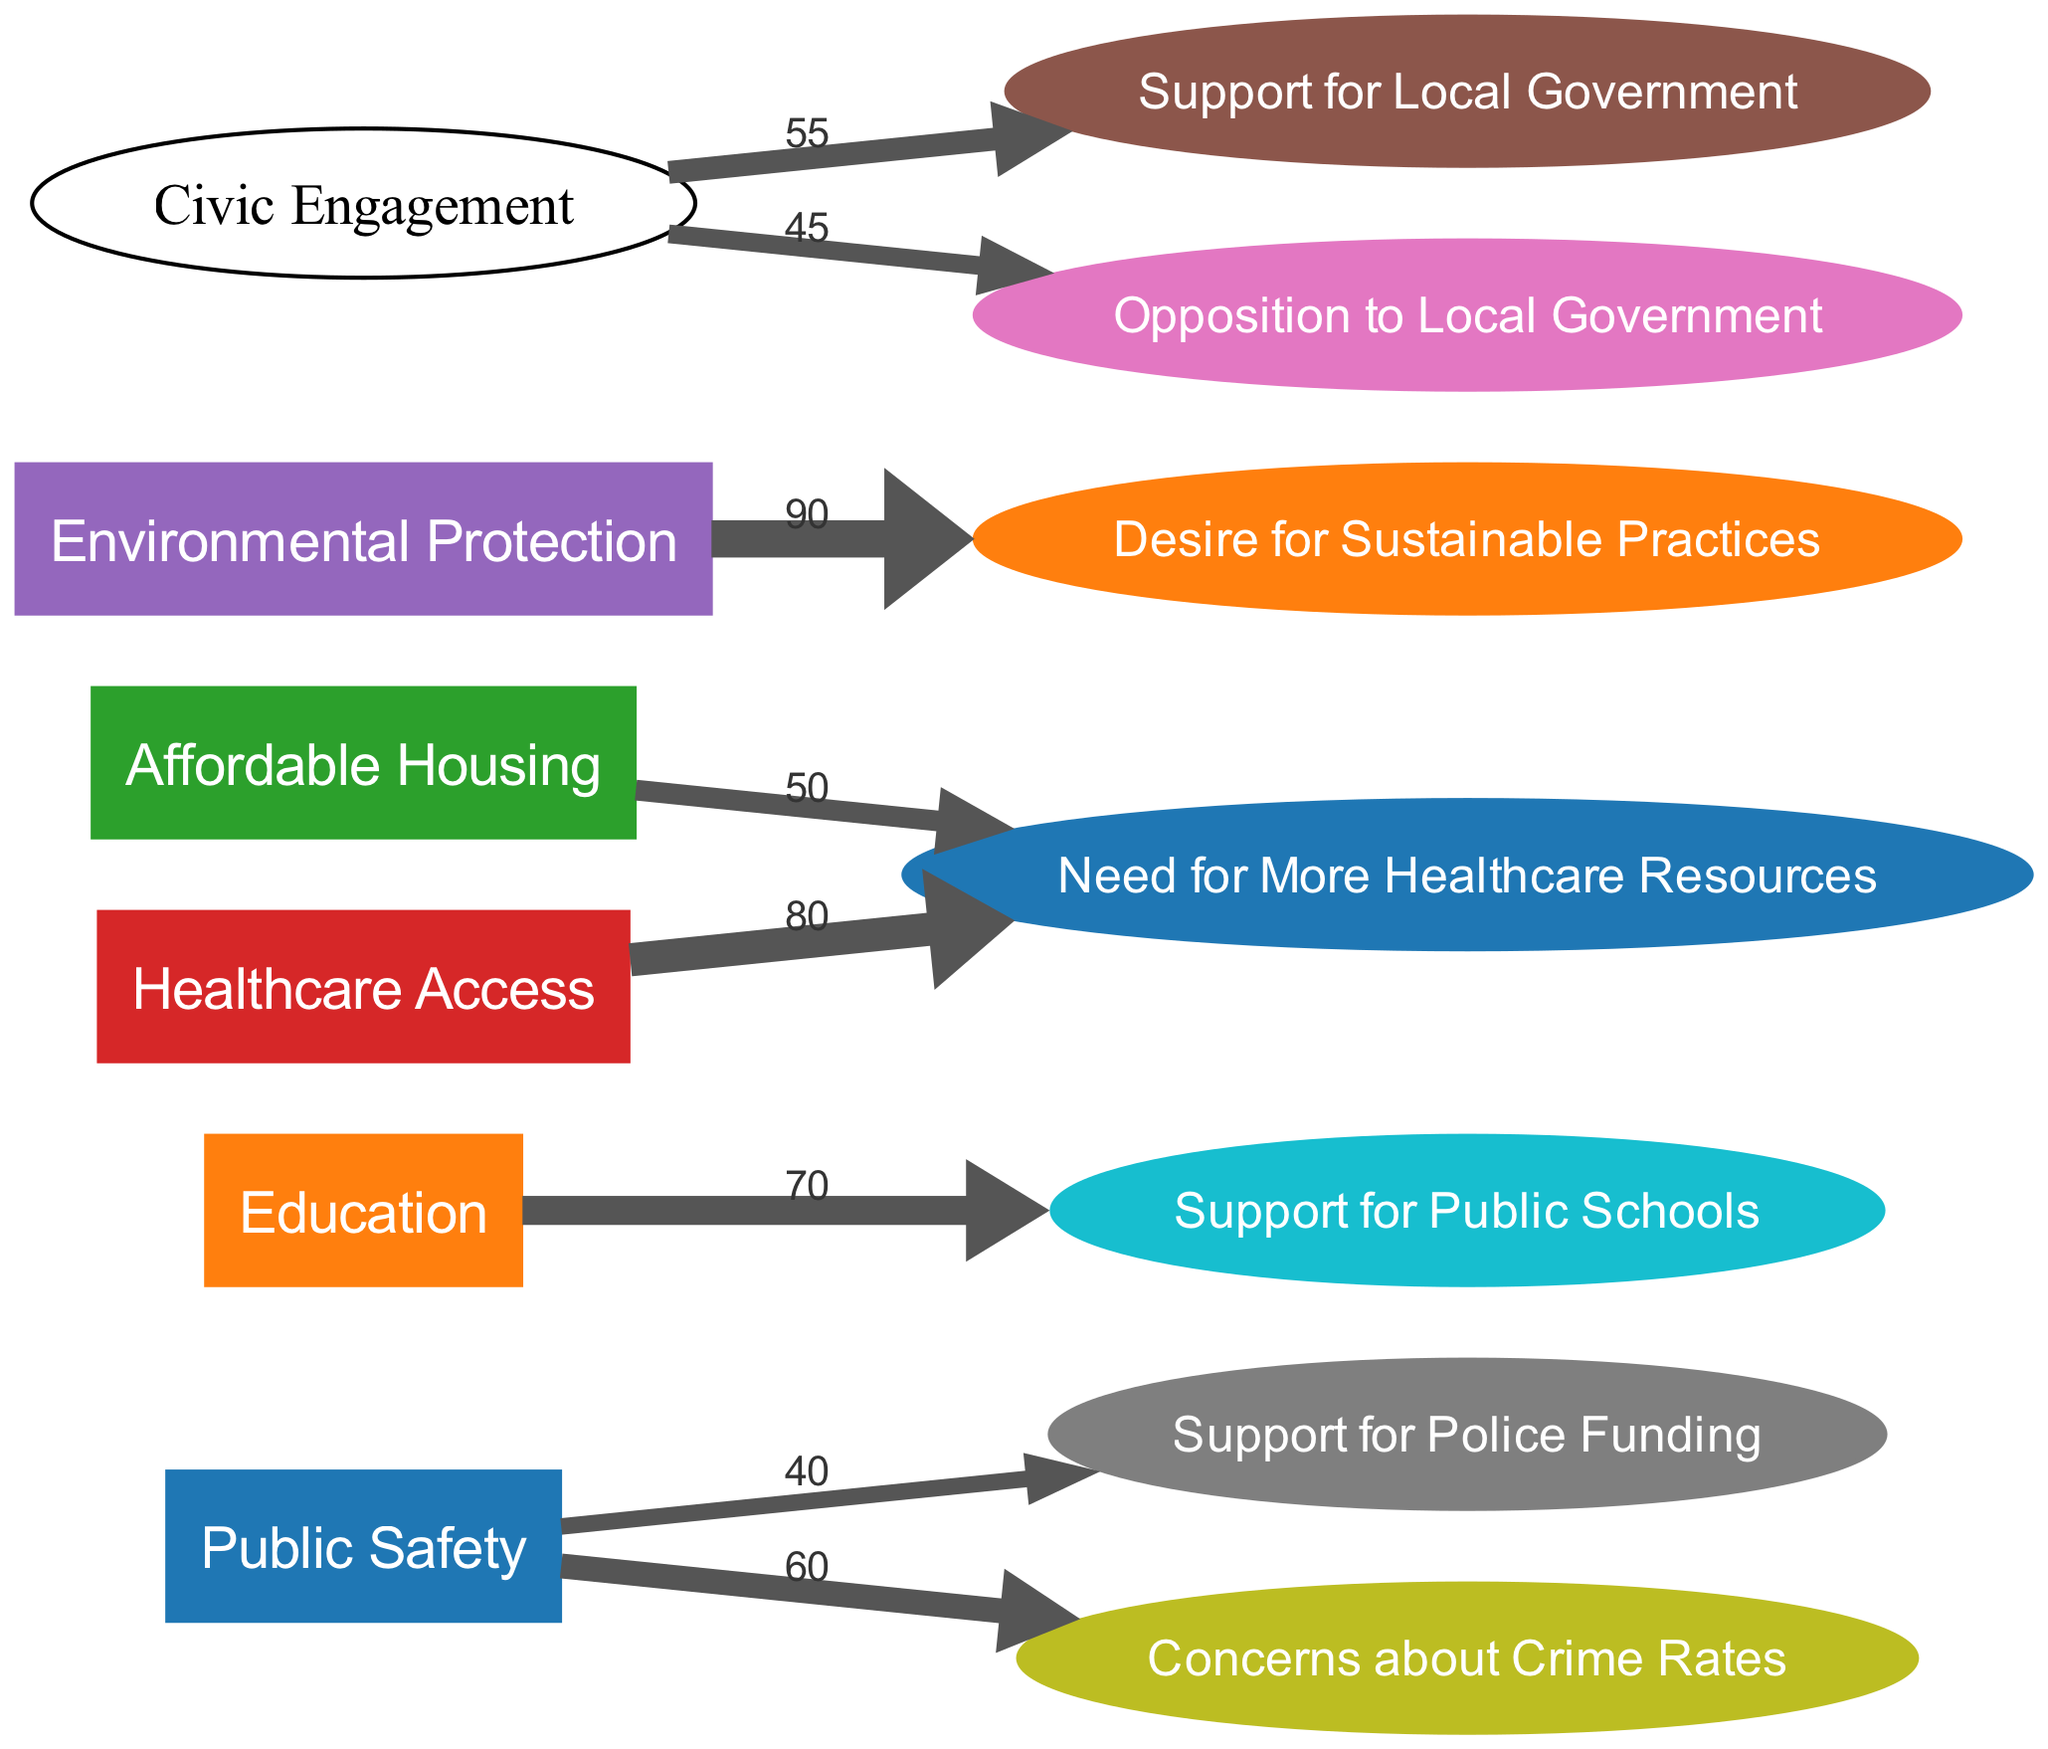What is the value of support for police funding? The diagram shows a direct link from the "Public Safety" issue to the "Support for Police Funding" opinion, with a value of 40.
Answer: 40 How many nodes are in the diagram? The diagram contains a total of 12 nodes, which include both issues and opinions.
Answer: 12 Which opinion is linked to both affordable housing and healthcare access? The "Need for More Healthcare Resources" opinion is connected to both the "Affordable Housing" and "Healthcare Access" issues, with values shown in the links.
Answer: Need for More Healthcare Resources What is the highest value of support for an opinion in the diagram? The highest value in the diagram is for the "Desire for Sustainable Practices" opinion, which is linked to the "Environmental Protection" issue with a value of 90.
Answer: 90 Which issue has the most connections to opinions in the diagram? The "Healthcare Access" issue is linked to one opinion only, but it has the highest value along with "Education" linked to "Support for Public Schools", which has another high value. The "Public Safety" issue connects to two opinions but with lower values overall. Overall, "Healthcare Access" links to "Need for More Healthcare Resources" with a value of 80, making it more influential on that opinion. Therefore, "Healthcare Access" has significant connection impact.
Answer: Healthcare Access What is the total value of the opinions connected to public safety? Adding the values of the links connected to "Public Safety," we have 40 for "Support for Police Funding" and 60 for "Concerns about Crime Rates," resulting in a total of 100.
Answer: 100 Which two opinions have nearly equal support and opposition in civic engagement? The opinions "Support for Local Government" with a value of 55 and "Opposition to Local Government" with a value of 45 are connected to "Civic Engagement." Both values indicate close proximity in public opinion towards engagement with local governance.
Answer: Support for Local Government and Opposition to Local Government In terms of sustainable practices, how many support values are presented in the diagram? The "Desire for Sustainable Practices" opinion directly connects to the "Environmental Protection" issue in the diagram, representing a singular focus on sustainability within the provided nodes. Thus, 1 supporting value is presented.
Answer: 1 What is the total value of survey responses focusing on healthcare resources? There are two links related to healthcare resources: one from "Affordable Housing" with a value of 50 and another from "Healthcare Access" with a value of 80, adding these together gives a total of 130 for healthcare resources focus.
Answer: 130 